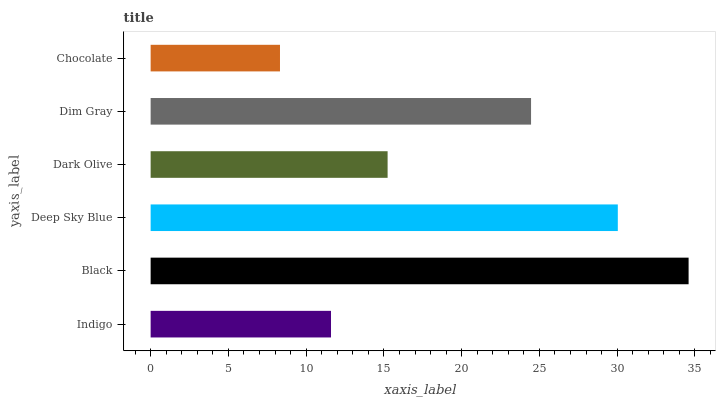Is Chocolate the minimum?
Answer yes or no. Yes. Is Black the maximum?
Answer yes or no. Yes. Is Deep Sky Blue the minimum?
Answer yes or no. No. Is Deep Sky Blue the maximum?
Answer yes or no. No. Is Black greater than Deep Sky Blue?
Answer yes or no. Yes. Is Deep Sky Blue less than Black?
Answer yes or no. Yes. Is Deep Sky Blue greater than Black?
Answer yes or no. No. Is Black less than Deep Sky Blue?
Answer yes or no. No. Is Dim Gray the high median?
Answer yes or no. Yes. Is Dark Olive the low median?
Answer yes or no. Yes. Is Deep Sky Blue the high median?
Answer yes or no. No. Is Dim Gray the low median?
Answer yes or no. No. 